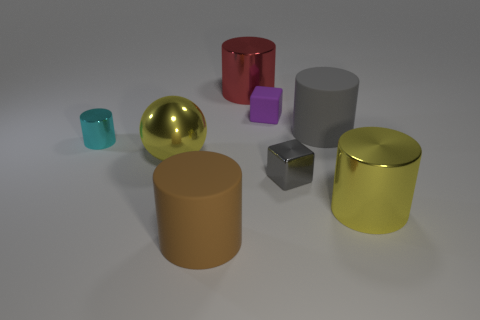What is the size of the purple cube that is the same material as the large gray object?
Ensure brevity in your answer.  Small. What size is the gray rubber thing that is the same shape as the large red shiny object?
Provide a short and direct response. Large. Are any large red metal cylinders visible?
Your answer should be very brief. Yes. How many objects are either shiny things that are on the right side of the large yellow shiny sphere or large red shiny objects?
Make the answer very short. 3. There is a cylinder that is the same size as the rubber block; what is its material?
Make the answer very short. Metal. The big metal object to the left of the big cylinder that is behind the purple object is what color?
Ensure brevity in your answer.  Yellow. How many big brown matte cylinders are right of the large gray thing?
Make the answer very short. 0. The big sphere has what color?
Offer a very short reply. Yellow. What number of large things are brown matte things or matte cylinders?
Keep it short and to the point. 2. There is a matte thing in front of the big yellow metal cylinder; is it the same color as the large shiny thing to the right of the red object?
Offer a terse response. No. 